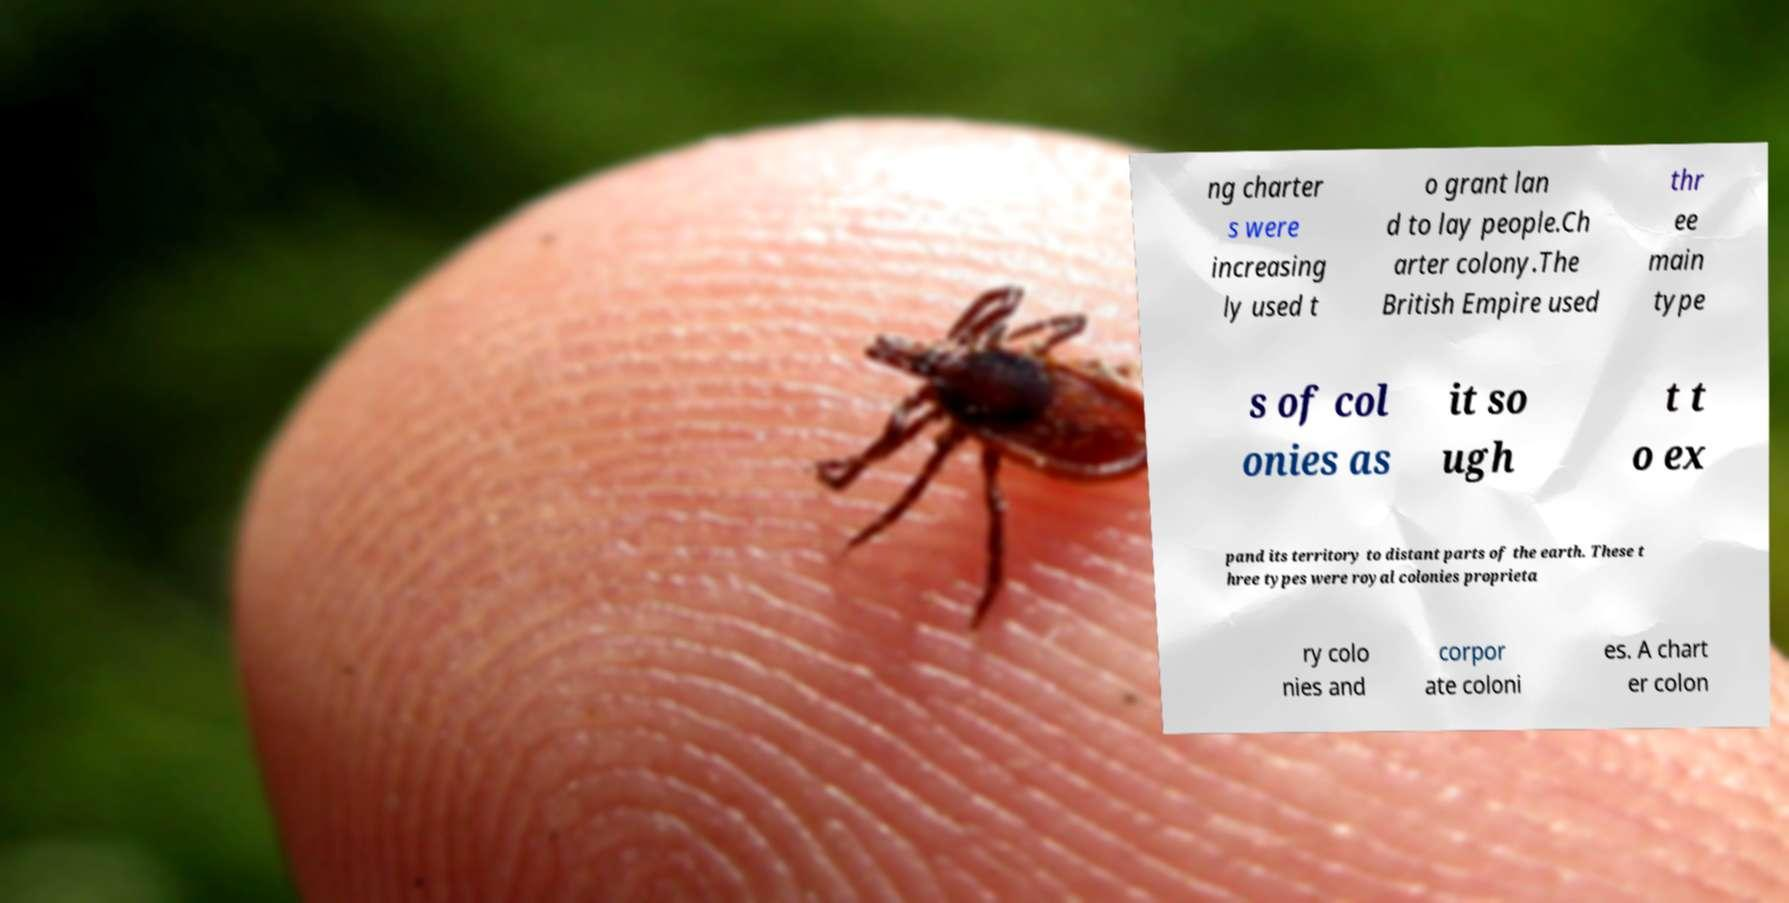Can you accurately transcribe the text from the provided image for me? ng charter s were increasing ly used t o grant lan d to lay people.Ch arter colony.The British Empire used thr ee main type s of col onies as it so ugh t t o ex pand its territory to distant parts of the earth. These t hree types were royal colonies proprieta ry colo nies and corpor ate coloni es. A chart er colon 